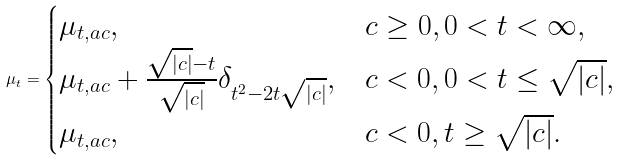<formula> <loc_0><loc_0><loc_500><loc_500>\mu _ { t } = \begin{cases} \mu _ { t , a c } , & c \geq 0 , 0 < t < \infty , \\ \mu _ { t , a c } + \frac { \sqrt { | c | } - t } { \sqrt { | c | } } \delta _ { t ^ { 2 } - 2 t \sqrt { | c | } } , & c < 0 , 0 < t \leq \sqrt { | c | } , \\ \mu _ { t , a c } , & c < 0 , t \geq \sqrt { | c | } . \end{cases}</formula> 